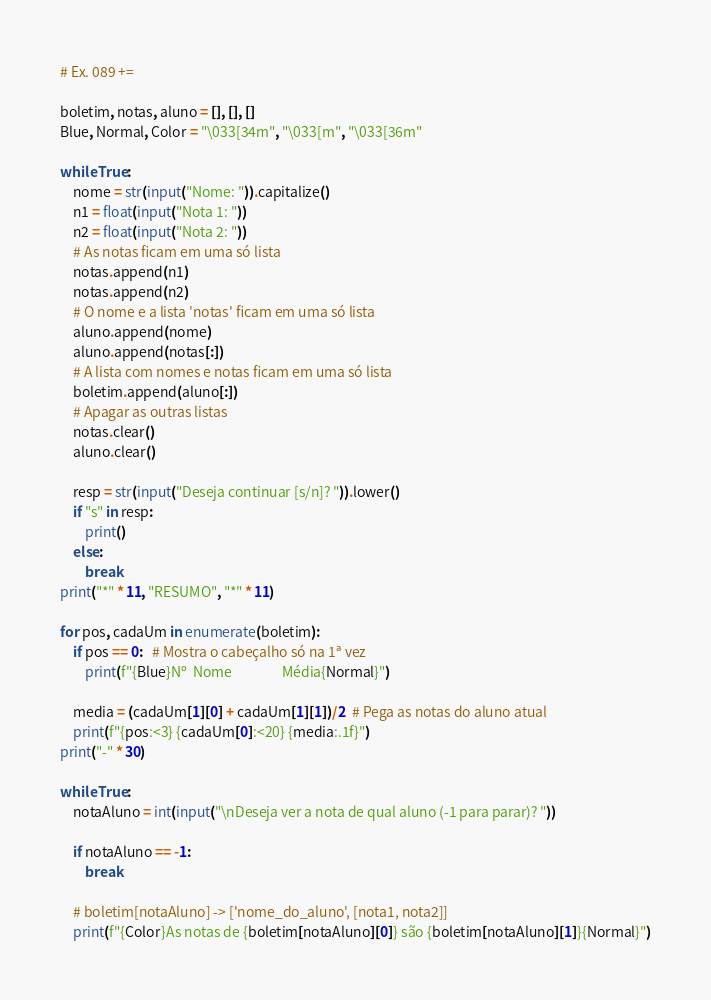Convert code to text. <code><loc_0><loc_0><loc_500><loc_500><_Python_># Ex. 089 +=

boletim, notas, aluno = [], [], []
Blue, Normal, Color = "\033[34m", "\033[m", "\033[36m"

while True:
    nome = str(input("Nome: ")).capitalize()
    n1 = float(input("Nota 1: "))
    n2 = float(input("Nota 2: "))
    # As notas ficam em uma só lista
    notas.append(n1)
    notas.append(n2)
    # O nome e a lista 'notas' ficam em uma só lista
    aluno.append(nome)
    aluno.append(notas[:])
    # A lista com nomes e notas ficam em uma só lista
    boletim.append(aluno[:])
    # Apagar as outras listas
    notas.clear()
    aluno.clear()

    resp = str(input("Deseja continuar [s/n]? ")).lower()
    if "s" in resp:
        print()
    else:
        break
print("*" * 11, "RESUMO", "*" * 11)

for pos, cadaUm in enumerate(boletim):
    if pos == 0:   # Mostra o cabeçalho só na 1ª vez
        print(f"{Blue}Nº  Nome                Média{Normal}")

    media = (cadaUm[1][0] + cadaUm[1][1])/2  # Pega as notas do aluno atual
    print(f"{pos:<3} {cadaUm[0]:<20} {media:.1f}")
print("-" * 30)

while True:
    notaAluno = int(input("\nDeseja ver a nota de qual aluno (-1 para parar)? "))

    if notaAluno == -1:
        break

    # boletim[notaAluno] -> ['nome_do_aluno', [nota1, nota2]]
    print(f"{Color}As notas de {boletim[notaAluno][0]} são {boletim[notaAluno][1]}{Normal}")
</code> 